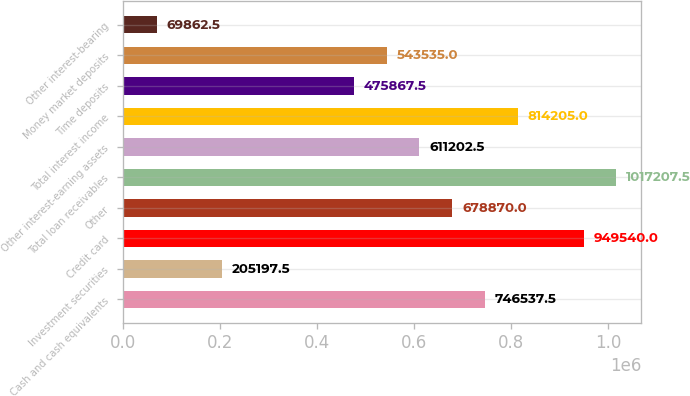<chart> <loc_0><loc_0><loc_500><loc_500><bar_chart><fcel>Cash and cash equivalents<fcel>Investment securities<fcel>Credit card<fcel>Other<fcel>Total loan receivables<fcel>Other interest-earning assets<fcel>Total interest income<fcel>Time deposits<fcel>Money market deposits<fcel>Other interest-bearing<nl><fcel>746538<fcel>205198<fcel>949540<fcel>678870<fcel>1.01721e+06<fcel>611202<fcel>814205<fcel>475868<fcel>543535<fcel>69862.5<nl></chart> 